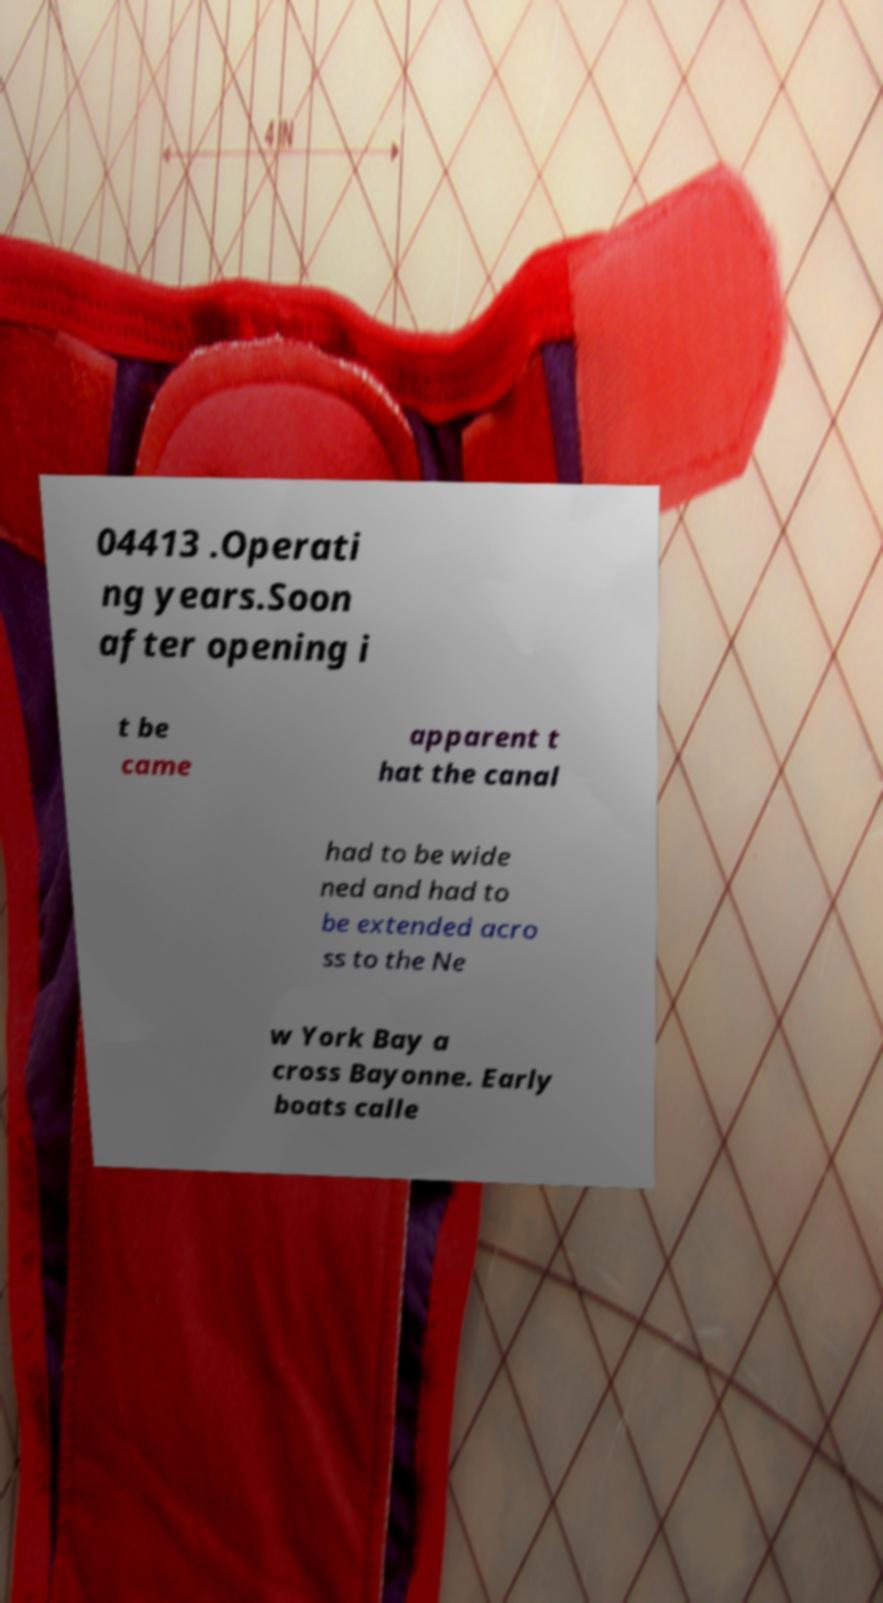Can you accurately transcribe the text from the provided image for me? 04413 .Operati ng years.Soon after opening i t be came apparent t hat the canal had to be wide ned and had to be extended acro ss to the Ne w York Bay a cross Bayonne. Early boats calle 